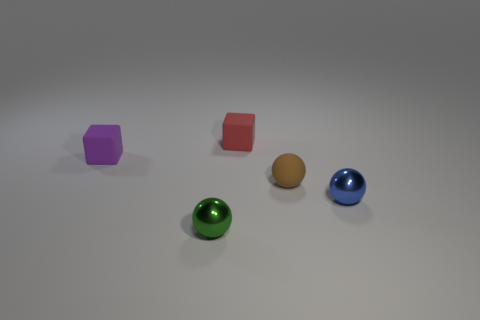Add 2 tiny purple rubber blocks. How many objects exist? 7 Subtract all cubes. How many objects are left? 3 Subtract all small green shiny cubes. Subtract all small purple rubber objects. How many objects are left? 4 Add 4 tiny purple objects. How many tiny purple objects are left? 5 Add 4 large red blocks. How many large red blocks exist? 4 Subtract 0 yellow cubes. How many objects are left? 5 